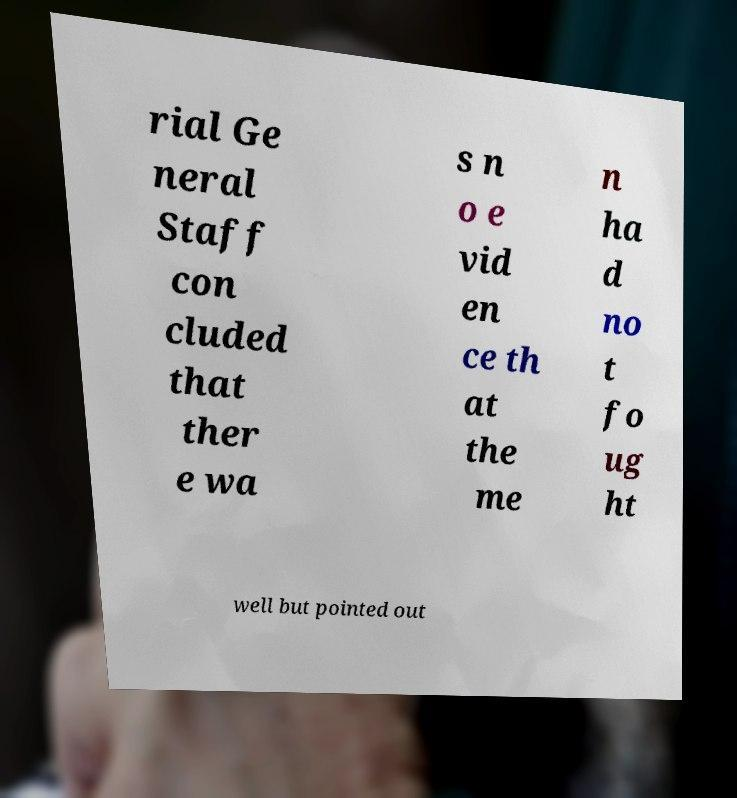There's text embedded in this image that I need extracted. Can you transcribe it verbatim? rial Ge neral Staff con cluded that ther e wa s n o e vid en ce th at the me n ha d no t fo ug ht well but pointed out 